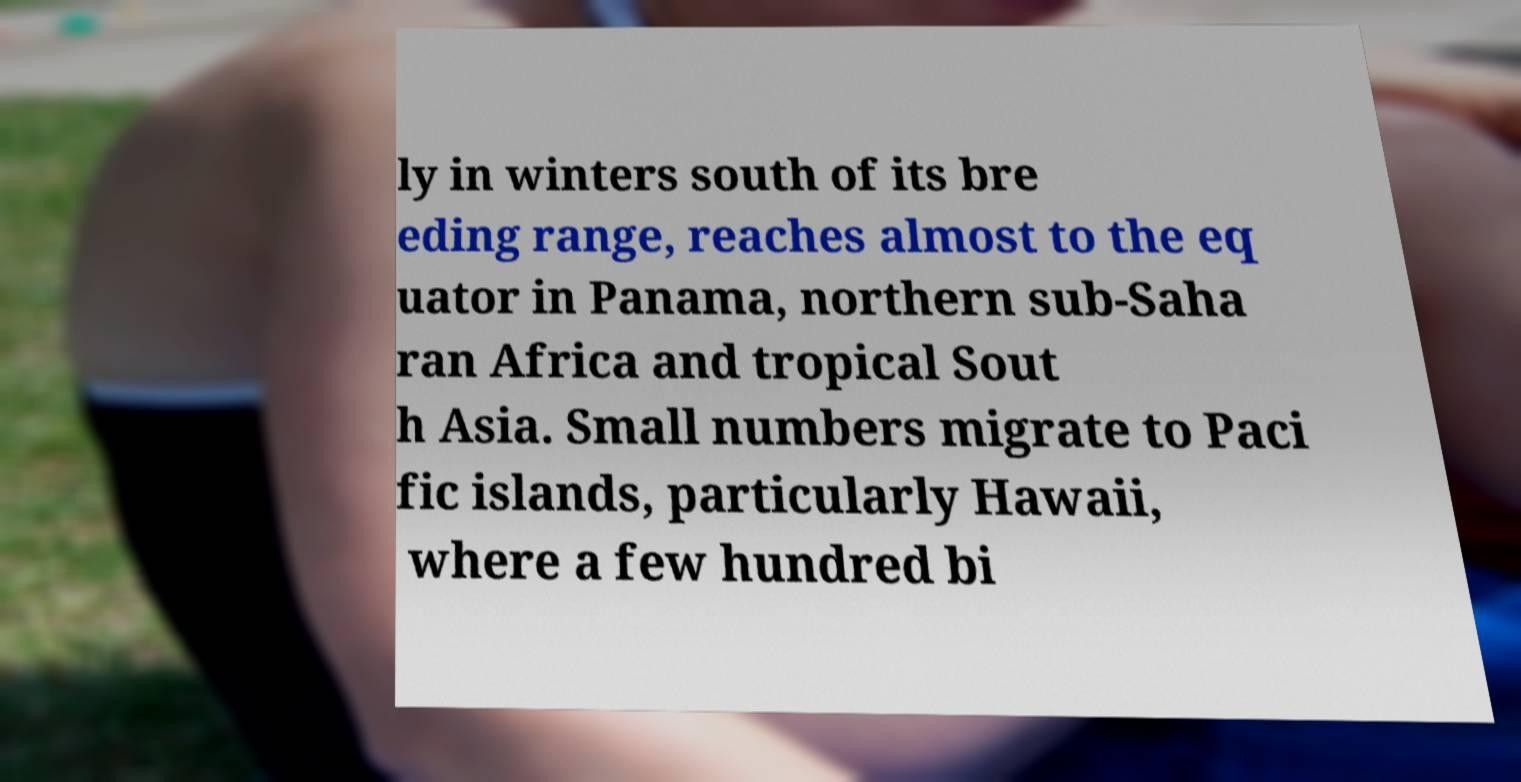For documentation purposes, I need the text within this image transcribed. Could you provide that? ly in winters south of its bre eding range, reaches almost to the eq uator in Panama, northern sub-Saha ran Africa and tropical Sout h Asia. Small numbers migrate to Paci fic islands, particularly Hawaii, where a few hundred bi 